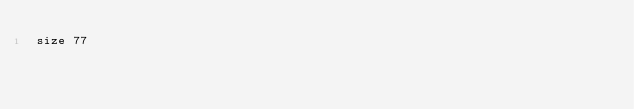<code> <loc_0><loc_0><loc_500><loc_500><_YAML_>size 77
</code> 